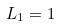Convert formula to latex. <formula><loc_0><loc_0><loc_500><loc_500>L _ { 1 } = 1</formula> 